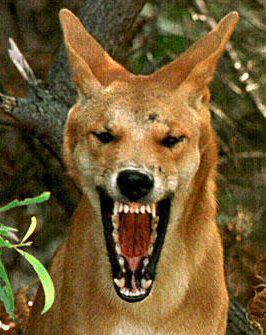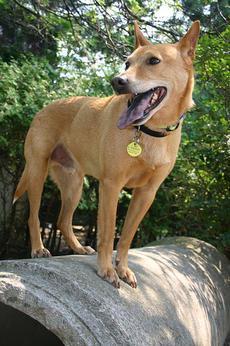The first image is the image on the left, the second image is the image on the right. For the images displayed, is the sentence "at lest one dog is showing its teeth" factually correct? Answer yes or no. Yes. 